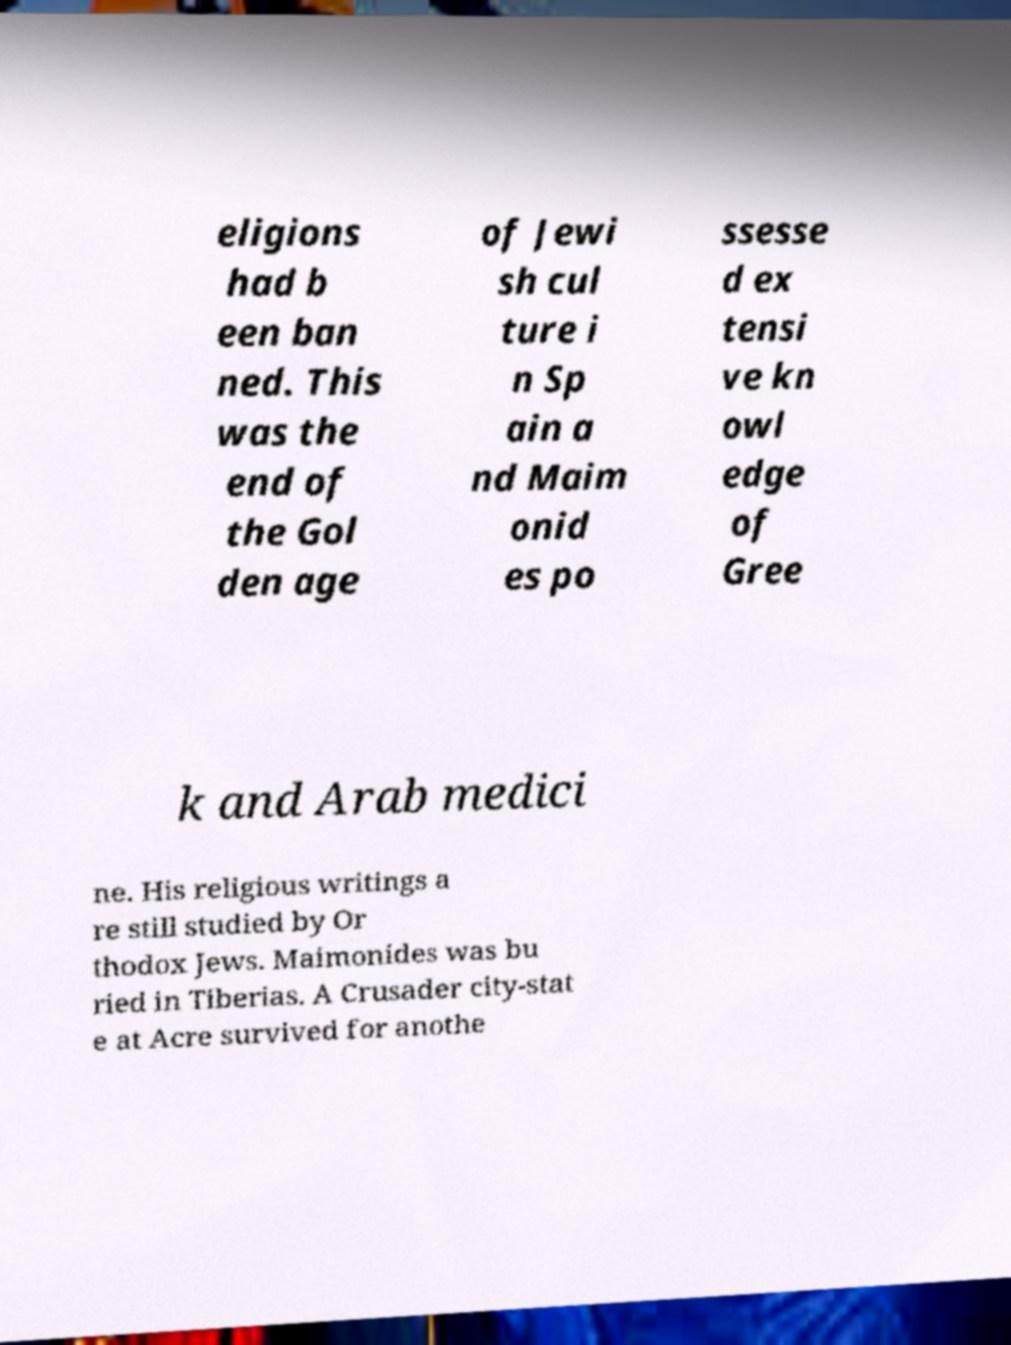Can you accurately transcribe the text from the provided image for me? eligions had b een ban ned. This was the end of the Gol den age of Jewi sh cul ture i n Sp ain a nd Maim onid es po ssesse d ex tensi ve kn owl edge of Gree k and Arab medici ne. His religious writings a re still studied by Or thodox Jews. Maimonides was bu ried in Tiberias. A Crusader city-stat e at Acre survived for anothe 